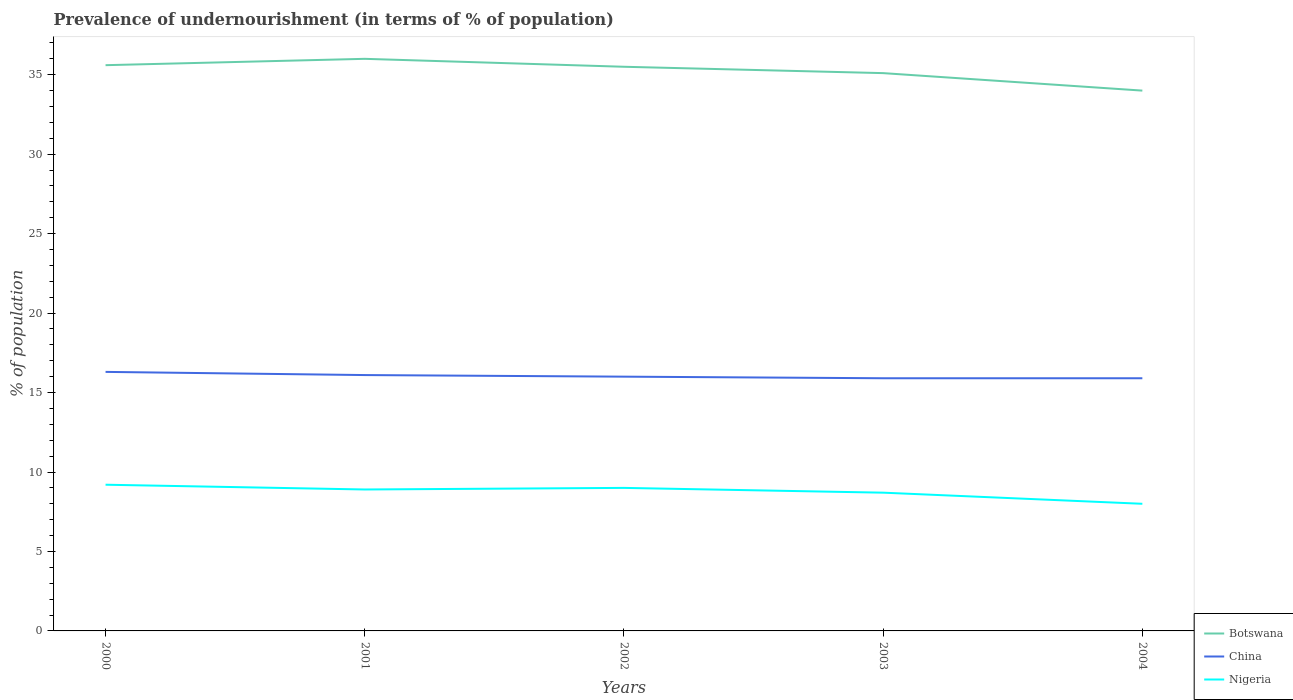How many different coloured lines are there?
Ensure brevity in your answer.  3. Across all years, what is the maximum percentage of undernourished population in Botswana?
Make the answer very short. 34. In which year was the percentage of undernourished population in China maximum?
Provide a short and direct response. 2003. What is the total percentage of undernourished population in Botswana in the graph?
Give a very brief answer. 1.6. How many years are there in the graph?
Your answer should be compact. 5. What is the difference between two consecutive major ticks on the Y-axis?
Keep it short and to the point. 5. How many legend labels are there?
Ensure brevity in your answer.  3. What is the title of the graph?
Your answer should be very brief. Prevalence of undernourishment (in terms of % of population). What is the label or title of the Y-axis?
Ensure brevity in your answer.  % of population. What is the % of population of Botswana in 2000?
Make the answer very short. 35.6. What is the % of population of China in 2000?
Ensure brevity in your answer.  16.3. What is the % of population in Botswana in 2001?
Your response must be concise. 36. What is the % of population in China in 2001?
Give a very brief answer. 16.1. What is the % of population of Nigeria in 2001?
Make the answer very short. 8.9. What is the % of population of Botswana in 2002?
Your answer should be compact. 35.5. What is the % of population of China in 2002?
Your answer should be very brief. 16. What is the % of population in Botswana in 2003?
Offer a terse response. 35.1. What is the % of population in Nigeria in 2003?
Offer a very short reply. 8.7. What is the % of population of Botswana in 2004?
Your answer should be very brief. 34. What is the % of population in Nigeria in 2004?
Make the answer very short. 8. Across all years, what is the maximum % of population of Nigeria?
Provide a succinct answer. 9.2. Across all years, what is the minimum % of population in China?
Ensure brevity in your answer.  15.9. Across all years, what is the minimum % of population in Nigeria?
Make the answer very short. 8. What is the total % of population in Botswana in the graph?
Give a very brief answer. 176.2. What is the total % of population of China in the graph?
Provide a succinct answer. 80.2. What is the total % of population in Nigeria in the graph?
Your answer should be very brief. 43.8. What is the difference between the % of population of Botswana in 2000 and that in 2001?
Ensure brevity in your answer.  -0.4. What is the difference between the % of population of China in 2000 and that in 2001?
Your response must be concise. 0.2. What is the difference between the % of population in Nigeria in 2000 and that in 2001?
Offer a very short reply. 0.3. What is the difference between the % of population of China in 2000 and that in 2002?
Keep it short and to the point. 0.3. What is the difference between the % of population of Nigeria in 2000 and that in 2002?
Provide a short and direct response. 0.2. What is the difference between the % of population of Nigeria in 2000 and that in 2003?
Provide a short and direct response. 0.5. What is the difference between the % of population in Botswana in 2000 and that in 2004?
Keep it short and to the point. 1.6. What is the difference between the % of population in Nigeria in 2000 and that in 2004?
Provide a short and direct response. 1.2. What is the difference between the % of population of China in 2001 and that in 2002?
Provide a short and direct response. 0.1. What is the difference between the % of population in Nigeria in 2001 and that in 2002?
Provide a succinct answer. -0.1. What is the difference between the % of population of China in 2001 and that in 2004?
Your answer should be compact. 0.2. What is the difference between the % of population in Nigeria in 2002 and that in 2003?
Provide a succinct answer. 0.3. What is the difference between the % of population of China in 2003 and that in 2004?
Make the answer very short. 0. What is the difference between the % of population of Botswana in 2000 and the % of population of China in 2001?
Offer a very short reply. 19.5. What is the difference between the % of population of Botswana in 2000 and the % of population of Nigeria in 2001?
Provide a succinct answer. 26.7. What is the difference between the % of population in China in 2000 and the % of population in Nigeria in 2001?
Offer a very short reply. 7.4. What is the difference between the % of population in Botswana in 2000 and the % of population in China in 2002?
Your answer should be compact. 19.6. What is the difference between the % of population of Botswana in 2000 and the % of population of Nigeria in 2002?
Offer a terse response. 26.6. What is the difference between the % of population of China in 2000 and the % of population of Nigeria in 2002?
Your answer should be very brief. 7.3. What is the difference between the % of population of Botswana in 2000 and the % of population of Nigeria in 2003?
Make the answer very short. 26.9. What is the difference between the % of population of China in 2000 and the % of population of Nigeria in 2003?
Offer a terse response. 7.6. What is the difference between the % of population in Botswana in 2000 and the % of population in Nigeria in 2004?
Keep it short and to the point. 27.6. What is the difference between the % of population of China in 2000 and the % of population of Nigeria in 2004?
Offer a terse response. 8.3. What is the difference between the % of population of Botswana in 2001 and the % of population of China in 2002?
Give a very brief answer. 20. What is the difference between the % of population in Botswana in 2001 and the % of population in China in 2003?
Your answer should be very brief. 20.1. What is the difference between the % of population in Botswana in 2001 and the % of population in Nigeria in 2003?
Your response must be concise. 27.3. What is the difference between the % of population of Botswana in 2001 and the % of population of China in 2004?
Make the answer very short. 20.1. What is the difference between the % of population of Botswana in 2001 and the % of population of Nigeria in 2004?
Provide a succinct answer. 28. What is the difference between the % of population of Botswana in 2002 and the % of population of China in 2003?
Make the answer very short. 19.6. What is the difference between the % of population in Botswana in 2002 and the % of population in Nigeria in 2003?
Ensure brevity in your answer.  26.8. What is the difference between the % of population of Botswana in 2002 and the % of population of China in 2004?
Provide a short and direct response. 19.6. What is the difference between the % of population in China in 2002 and the % of population in Nigeria in 2004?
Offer a very short reply. 8. What is the difference between the % of population in Botswana in 2003 and the % of population in China in 2004?
Keep it short and to the point. 19.2. What is the difference between the % of population of Botswana in 2003 and the % of population of Nigeria in 2004?
Ensure brevity in your answer.  27.1. What is the average % of population in Botswana per year?
Provide a succinct answer. 35.24. What is the average % of population of China per year?
Provide a short and direct response. 16.04. What is the average % of population of Nigeria per year?
Keep it short and to the point. 8.76. In the year 2000, what is the difference between the % of population in Botswana and % of population in China?
Make the answer very short. 19.3. In the year 2000, what is the difference between the % of population in Botswana and % of population in Nigeria?
Ensure brevity in your answer.  26.4. In the year 2001, what is the difference between the % of population in Botswana and % of population in China?
Make the answer very short. 19.9. In the year 2001, what is the difference between the % of population of Botswana and % of population of Nigeria?
Ensure brevity in your answer.  27.1. In the year 2001, what is the difference between the % of population of China and % of population of Nigeria?
Your response must be concise. 7.2. In the year 2003, what is the difference between the % of population in Botswana and % of population in Nigeria?
Provide a succinct answer. 26.4. In the year 2004, what is the difference between the % of population in Botswana and % of population in China?
Keep it short and to the point. 18.1. In the year 2004, what is the difference between the % of population in China and % of population in Nigeria?
Your answer should be very brief. 7.9. What is the ratio of the % of population in Botswana in 2000 to that in 2001?
Give a very brief answer. 0.99. What is the ratio of the % of population of China in 2000 to that in 2001?
Ensure brevity in your answer.  1.01. What is the ratio of the % of population in Nigeria in 2000 to that in 2001?
Offer a very short reply. 1.03. What is the ratio of the % of population in China in 2000 to that in 2002?
Offer a terse response. 1.02. What is the ratio of the % of population in Nigeria in 2000 to that in 2002?
Offer a very short reply. 1.02. What is the ratio of the % of population in Botswana in 2000 to that in 2003?
Your answer should be compact. 1.01. What is the ratio of the % of population in China in 2000 to that in 2003?
Make the answer very short. 1.03. What is the ratio of the % of population of Nigeria in 2000 to that in 2003?
Provide a short and direct response. 1.06. What is the ratio of the % of population of Botswana in 2000 to that in 2004?
Offer a very short reply. 1.05. What is the ratio of the % of population in China in 2000 to that in 2004?
Provide a short and direct response. 1.03. What is the ratio of the % of population in Nigeria in 2000 to that in 2004?
Ensure brevity in your answer.  1.15. What is the ratio of the % of population of Botswana in 2001 to that in 2002?
Offer a very short reply. 1.01. What is the ratio of the % of population of China in 2001 to that in 2002?
Give a very brief answer. 1.01. What is the ratio of the % of population of Nigeria in 2001 to that in 2002?
Provide a short and direct response. 0.99. What is the ratio of the % of population of Botswana in 2001 to that in 2003?
Make the answer very short. 1.03. What is the ratio of the % of population in China in 2001 to that in 2003?
Provide a short and direct response. 1.01. What is the ratio of the % of population of Nigeria in 2001 to that in 2003?
Make the answer very short. 1.02. What is the ratio of the % of population in Botswana in 2001 to that in 2004?
Make the answer very short. 1.06. What is the ratio of the % of population of China in 2001 to that in 2004?
Your answer should be very brief. 1.01. What is the ratio of the % of population of Nigeria in 2001 to that in 2004?
Make the answer very short. 1.11. What is the ratio of the % of population of Botswana in 2002 to that in 2003?
Your response must be concise. 1.01. What is the ratio of the % of population of China in 2002 to that in 2003?
Keep it short and to the point. 1.01. What is the ratio of the % of population in Nigeria in 2002 to that in 2003?
Ensure brevity in your answer.  1.03. What is the ratio of the % of population of Botswana in 2002 to that in 2004?
Your answer should be very brief. 1.04. What is the ratio of the % of population of China in 2002 to that in 2004?
Your answer should be very brief. 1.01. What is the ratio of the % of population of Botswana in 2003 to that in 2004?
Provide a succinct answer. 1.03. What is the ratio of the % of population in Nigeria in 2003 to that in 2004?
Ensure brevity in your answer.  1.09. What is the difference between the highest and the second highest % of population of Nigeria?
Your answer should be compact. 0.2. What is the difference between the highest and the lowest % of population of Botswana?
Provide a succinct answer. 2. 